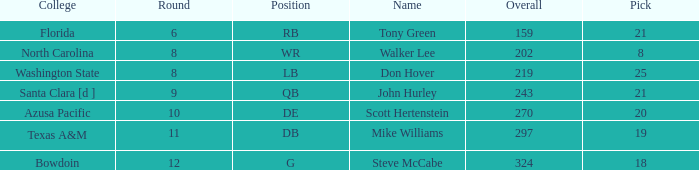Which college has a pick less than 25, an overall greater than 159, a round less than 10, and wr as the position? North Carolina. 